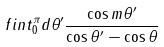<formula> <loc_0><loc_0><loc_500><loc_500>\ f i n t _ { 0 } ^ { \pi } d \theta ^ { \prime } \frac { \cos m \theta ^ { \prime } } { \cos \theta ^ { \prime } - \cos \theta }</formula> 